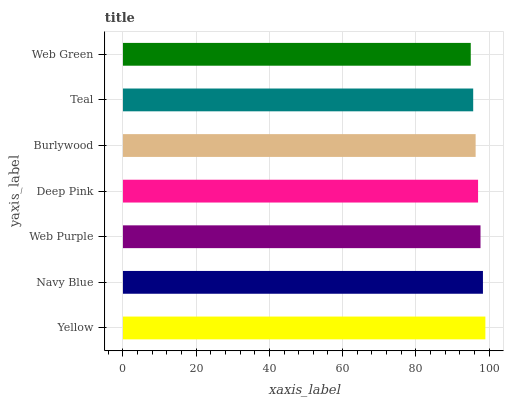Is Web Green the minimum?
Answer yes or no. Yes. Is Yellow the maximum?
Answer yes or no. Yes. Is Navy Blue the minimum?
Answer yes or no. No. Is Navy Blue the maximum?
Answer yes or no. No. Is Yellow greater than Navy Blue?
Answer yes or no. Yes. Is Navy Blue less than Yellow?
Answer yes or no. Yes. Is Navy Blue greater than Yellow?
Answer yes or no. No. Is Yellow less than Navy Blue?
Answer yes or no. No. Is Deep Pink the high median?
Answer yes or no. Yes. Is Deep Pink the low median?
Answer yes or no. Yes. Is Web Green the high median?
Answer yes or no. No. Is Web Purple the low median?
Answer yes or no. No. 